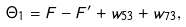<formula> <loc_0><loc_0><loc_500><loc_500>\Theta _ { 1 } = F - F ^ { \prime } + w _ { 5 3 } + w _ { 7 3 } ,</formula> 